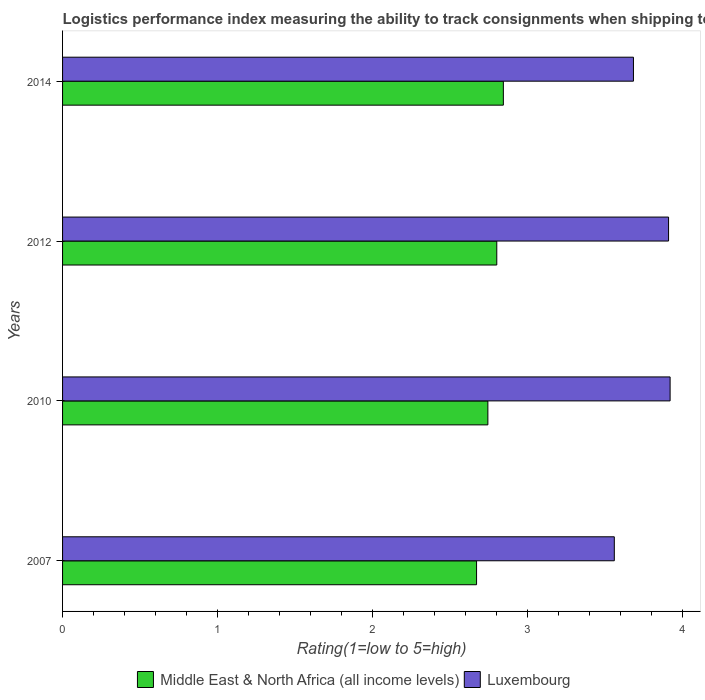How many different coloured bars are there?
Provide a short and direct response. 2. Are the number of bars on each tick of the Y-axis equal?
Your answer should be very brief. Yes. How many bars are there on the 2nd tick from the bottom?
Keep it short and to the point. 2. What is the label of the 1st group of bars from the top?
Keep it short and to the point. 2014. What is the Logistic performance index in Middle East & North Africa (all income levels) in 2007?
Make the answer very short. 2.67. Across all years, what is the maximum Logistic performance index in Middle East & North Africa (all income levels)?
Offer a terse response. 2.84. Across all years, what is the minimum Logistic performance index in Middle East & North Africa (all income levels)?
Your response must be concise. 2.67. In which year was the Logistic performance index in Middle East & North Africa (all income levels) maximum?
Make the answer very short. 2014. What is the total Logistic performance index in Middle East & North Africa (all income levels) in the graph?
Provide a short and direct response. 11.06. What is the difference between the Logistic performance index in Middle East & North Africa (all income levels) in 2012 and that in 2014?
Your response must be concise. -0.04. What is the difference between the Logistic performance index in Luxembourg in 2010 and the Logistic performance index in Middle East & North Africa (all income levels) in 2007?
Provide a succinct answer. 1.25. What is the average Logistic performance index in Luxembourg per year?
Keep it short and to the point. 3.77. In the year 2010, what is the difference between the Logistic performance index in Luxembourg and Logistic performance index in Middle East & North Africa (all income levels)?
Your answer should be very brief. 1.18. In how many years, is the Logistic performance index in Middle East & North Africa (all income levels) greater than 1.6 ?
Make the answer very short. 4. What is the ratio of the Logistic performance index in Middle East & North Africa (all income levels) in 2010 to that in 2012?
Offer a terse response. 0.98. Is the Logistic performance index in Luxembourg in 2010 less than that in 2014?
Keep it short and to the point. No. Is the difference between the Logistic performance index in Luxembourg in 2010 and 2014 greater than the difference between the Logistic performance index in Middle East & North Africa (all income levels) in 2010 and 2014?
Your answer should be compact. Yes. What is the difference between the highest and the second highest Logistic performance index in Middle East & North Africa (all income levels)?
Offer a very short reply. 0.04. What is the difference between the highest and the lowest Logistic performance index in Middle East & North Africa (all income levels)?
Offer a very short reply. 0.17. What does the 2nd bar from the top in 2010 represents?
Make the answer very short. Middle East & North Africa (all income levels). What does the 2nd bar from the bottom in 2007 represents?
Keep it short and to the point. Luxembourg. How many bars are there?
Keep it short and to the point. 8. Are all the bars in the graph horizontal?
Make the answer very short. Yes. What is the difference between two consecutive major ticks on the X-axis?
Ensure brevity in your answer.  1. Are the values on the major ticks of X-axis written in scientific E-notation?
Give a very brief answer. No. Does the graph contain any zero values?
Your response must be concise. No. How are the legend labels stacked?
Keep it short and to the point. Horizontal. What is the title of the graph?
Offer a terse response. Logistics performance index measuring the ability to track consignments when shipping to a market. What is the label or title of the X-axis?
Ensure brevity in your answer.  Rating(1=low to 5=high). What is the label or title of the Y-axis?
Offer a very short reply. Years. What is the Rating(1=low to 5=high) in Middle East & North Africa (all income levels) in 2007?
Your response must be concise. 2.67. What is the Rating(1=low to 5=high) in Luxembourg in 2007?
Keep it short and to the point. 3.56. What is the Rating(1=low to 5=high) in Middle East & North Africa (all income levels) in 2010?
Ensure brevity in your answer.  2.74. What is the Rating(1=low to 5=high) in Luxembourg in 2010?
Provide a succinct answer. 3.92. What is the Rating(1=low to 5=high) in Middle East & North Africa (all income levels) in 2012?
Your answer should be compact. 2.8. What is the Rating(1=low to 5=high) in Luxembourg in 2012?
Make the answer very short. 3.91. What is the Rating(1=low to 5=high) of Middle East & North Africa (all income levels) in 2014?
Offer a very short reply. 2.84. What is the Rating(1=low to 5=high) of Luxembourg in 2014?
Give a very brief answer. 3.68. Across all years, what is the maximum Rating(1=low to 5=high) of Middle East & North Africa (all income levels)?
Your response must be concise. 2.84. Across all years, what is the maximum Rating(1=low to 5=high) in Luxembourg?
Your response must be concise. 3.92. Across all years, what is the minimum Rating(1=low to 5=high) in Middle East & North Africa (all income levels)?
Keep it short and to the point. 2.67. Across all years, what is the minimum Rating(1=low to 5=high) in Luxembourg?
Make the answer very short. 3.56. What is the total Rating(1=low to 5=high) in Middle East & North Africa (all income levels) in the graph?
Offer a very short reply. 11.06. What is the total Rating(1=low to 5=high) of Luxembourg in the graph?
Ensure brevity in your answer.  15.07. What is the difference between the Rating(1=low to 5=high) in Middle East & North Africa (all income levels) in 2007 and that in 2010?
Provide a succinct answer. -0.07. What is the difference between the Rating(1=low to 5=high) in Luxembourg in 2007 and that in 2010?
Offer a very short reply. -0.36. What is the difference between the Rating(1=low to 5=high) of Middle East & North Africa (all income levels) in 2007 and that in 2012?
Make the answer very short. -0.13. What is the difference between the Rating(1=low to 5=high) of Luxembourg in 2007 and that in 2012?
Offer a terse response. -0.35. What is the difference between the Rating(1=low to 5=high) of Middle East & North Africa (all income levels) in 2007 and that in 2014?
Offer a very short reply. -0.17. What is the difference between the Rating(1=low to 5=high) of Luxembourg in 2007 and that in 2014?
Ensure brevity in your answer.  -0.12. What is the difference between the Rating(1=low to 5=high) of Middle East & North Africa (all income levels) in 2010 and that in 2012?
Give a very brief answer. -0.06. What is the difference between the Rating(1=low to 5=high) of Luxembourg in 2010 and that in 2012?
Your answer should be compact. 0.01. What is the difference between the Rating(1=low to 5=high) of Middle East & North Africa (all income levels) in 2010 and that in 2014?
Ensure brevity in your answer.  -0.1. What is the difference between the Rating(1=low to 5=high) in Luxembourg in 2010 and that in 2014?
Provide a succinct answer. 0.24. What is the difference between the Rating(1=low to 5=high) of Middle East & North Africa (all income levels) in 2012 and that in 2014?
Make the answer very short. -0.04. What is the difference between the Rating(1=low to 5=high) of Luxembourg in 2012 and that in 2014?
Provide a short and direct response. 0.23. What is the difference between the Rating(1=low to 5=high) in Middle East & North Africa (all income levels) in 2007 and the Rating(1=low to 5=high) in Luxembourg in 2010?
Provide a short and direct response. -1.25. What is the difference between the Rating(1=low to 5=high) in Middle East & North Africa (all income levels) in 2007 and the Rating(1=low to 5=high) in Luxembourg in 2012?
Offer a very short reply. -1.24. What is the difference between the Rating(1=low to 5=high) of Middle East & North Africa (all income levels) in 2007 and the Rating(1=low to 5=high) of Luxembourg in 2014?
Provide a succinct answer. -1.01. What is the difference between the Rating(1=low to 5=high) of Middle East & North Africa (all income levels) in 2010 and the Rating(1=low to 5=high) of Luxembourg in 2012?
Your answer should be compact. -1.17. What is the difference between the Rating(1=low to 5=high) in Middle East & North Africa (all income levels) in 2010 and the Rating(1=low to 5=high) in Luxembourg in 2014?
Your answer should be very brief. -0.94. What is the difference between the Rating(1=low to 5=high) of Middle East & North Africa (all income levels) in 2012 and the Rating(1=low to 5=high) of Luxembourg in 2014?
Your answer should be very brief. -0.88. What is the average Rating(1=low to 5=high) in Middle East & North Africa (all income levels) per year?
Your response must be concise. 2.77. What is the average Rating(1=low to 5=high) of Luxembourg per year?
Your answer should be very brief. 3.77. In the year 2007, what is the difference between the Rating(1=low to 5=high) of Middle East & North Africa (all income levels) and Rating(1=low to 5=high) of Luxembourg?
Your answer should be very brief. -0.89. In the year 2010, what is the difference between the Rating(1=low to 5=high) in Middle East & North Africa (all income levels) and Rating(1=low to 5=high) in Luxembourg?
Your answer should be compact. -1.18. In the year 2012, what is the difference between the Rating(1=low to 5=high) in Middle East & North Africa (all income levels) and Rating(1=low to 5=high) in Luxembourg?
Ensure brevity in your answer.  -1.11. In the year 2014, what is the difference between the Rating(1=low to 5=high) in Middle East & North Africa (all income levels) and Rating(1=low to 5=high) in Luxembourg?
Keep it short and to the point. -0.84. What is the ratio of the Rating(1=low to 5=high) of Middle East & North Africa (all income levels) in 2007 to that in 2010?
Your answer should be very brief. 0.97. What is the ratio of the Rating(1=low to 5=high) in Luxembourg in 2007 to that in 2010?
Give a very brief answer. 0.91. What is the ratio of the Rating(1=low to 5=high) of Middle East & North Africa (all income levels) in 2007 to that in 2012?
Keep it short and to the point. 0.95. What is the ratio of the Rating(1=low to 5=high) in Luxembourg in 2007 to that in 2012?
Ensure brevity in your answer.  0.91. What is the ratio of the Rating(1=low to 5=high) in Middle East & North Africa (all income levels) in 2007 to that in 2014?
Ensure brevity in your answer.  0.94. What is the ratio of the Rating(1=low to 5=high) in Luxembourg in 2007 to that in 2014?
Your answer should be compact. 0.97. What is the ratio of the Rating(1=low to 5=high) of Middle East & North Africa (all income levels) in 2010 to that in 2012?
Offer a very short reply. 0.98. What is the ratio of the Rating(1=low to 5=high) of Luxembourg in 2010 to that in 2012?
Your answer should be compact. 1. What is the ratio of the Rating(1=low to 5=high) of Middle East & North Africa (all income levels) in 2010 to that in 2014?
Your answer should be very brief. 0.96. What is the ratio of the Rating(1=low to 5=high) of Luxembourg in 2010 to that in 2014?
Give a very brief answer. 1.06. What is the ratio of the Rating(1=low to 5=high) in Middle East & North Africa (all income levels) in 2012 to that in 2014?
Provide a short and direct response. 0.99. What is the ratio of the Rating(1=low to 5=high) of Luxembourg in 2012 to that in 2014?
Offer a very short reply. 1.06. What is the difference between the highest and the second highest Rating(1=low to 5=high) in Middle East & North Africa (all income levels)?
Make the answer very short. 0.04. What is the difference between the highest and the second highest Rating(1=low to 5=high) of Luxembourg?
Make the answer very short. 0.01. What is the difference between the highest and the lowest Rating(1=low to 5=high) of Middle East & North Africa (all income levels)?
Offer a very short reply. 0.17. What is the difference between the highest and the lowest Rating(1=low to 5=high) in Luxembourg?
Provide a short and direct response. 0.36. 